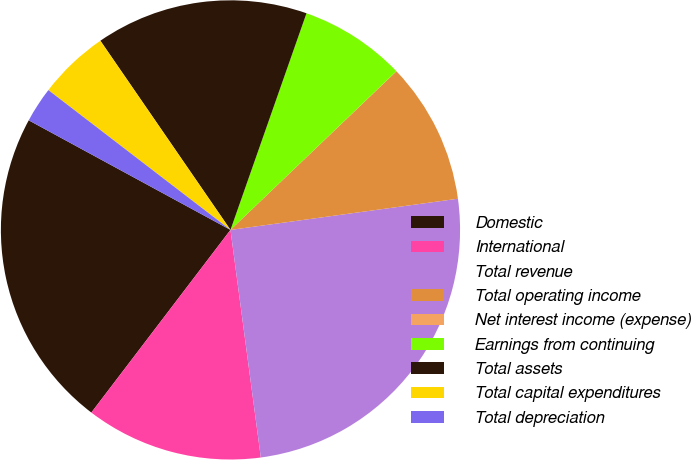Convert chart. <chart><loc_0><loc_0><loc_500><loc_500><pie_chart><fcel>Domestic<fcel>International<fcel>Total revenue<fcel>Total operating income<fcel>Net interest income (expense)<fcel>Earnings from continuing<fcel>Total assets<fcel>Total capital expenditures<fcel>Total depreciation<nl><fcel>22.56%<fcel>12.47%<fcel>25.06%<fcel>9.97%<fcel>0.01%<fcel>7.48%<fcel>14.96%<fcel>4.99%<fcel>2.5%<nl></chart> 